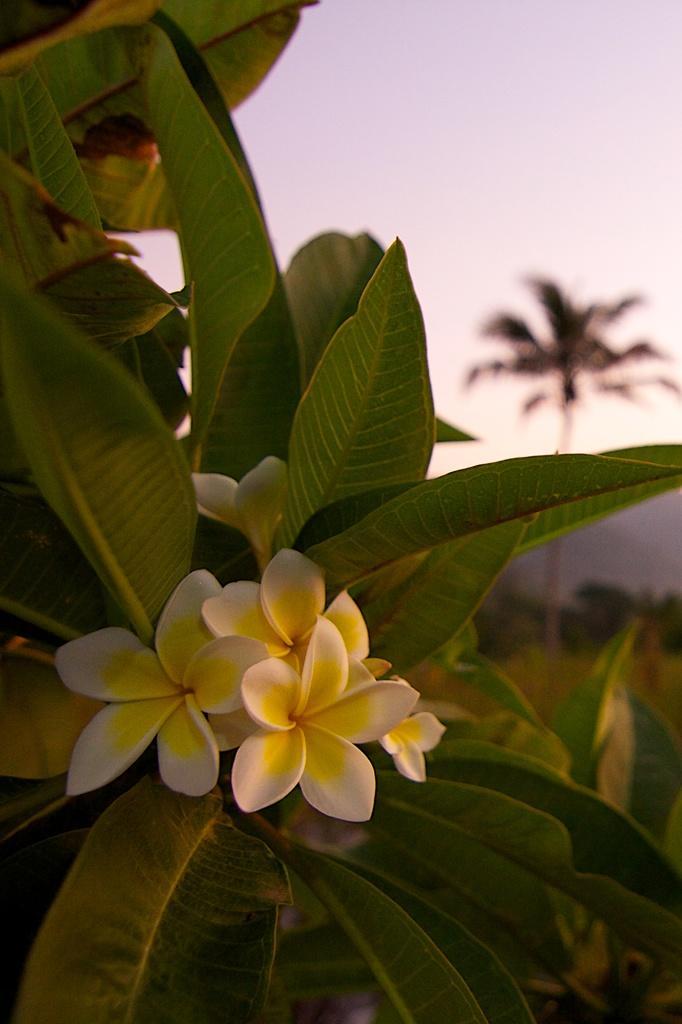Can you describe this image briefly? In this image there are flowers and leaves, in the background there are trees and it is blurred. 